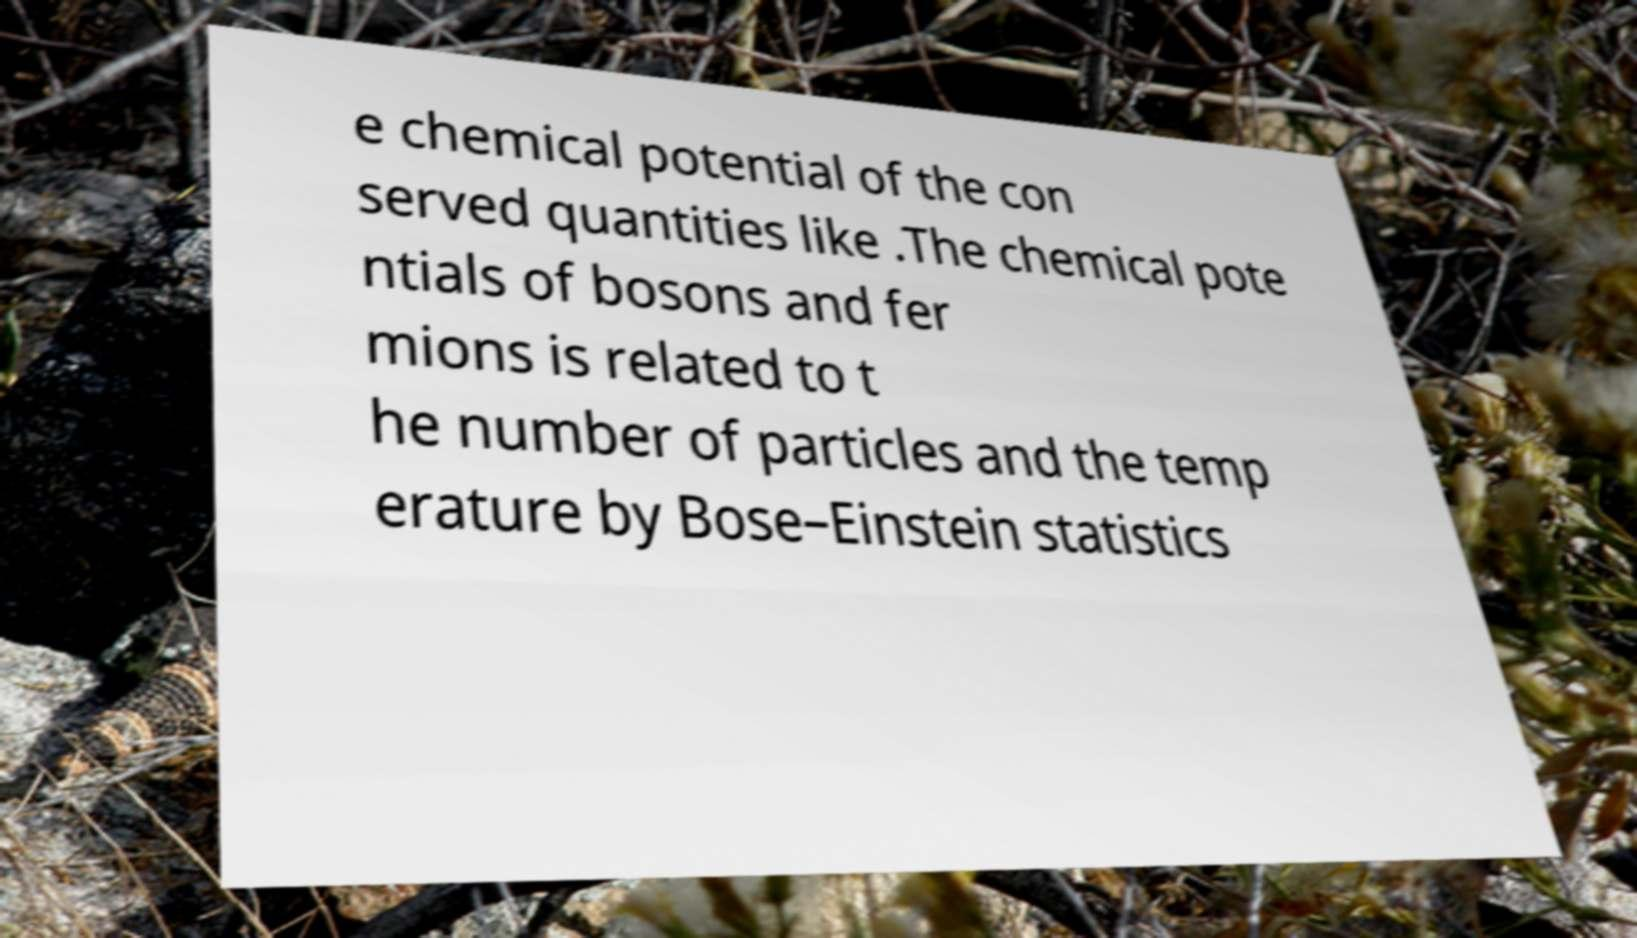Could you extract and type out the text from this image? e chemical potential of the con served quantities like .The chemical pote ntials of bosons and fer mions is related to t he number of particles and the temp erature by Bose–Einstein statistics 